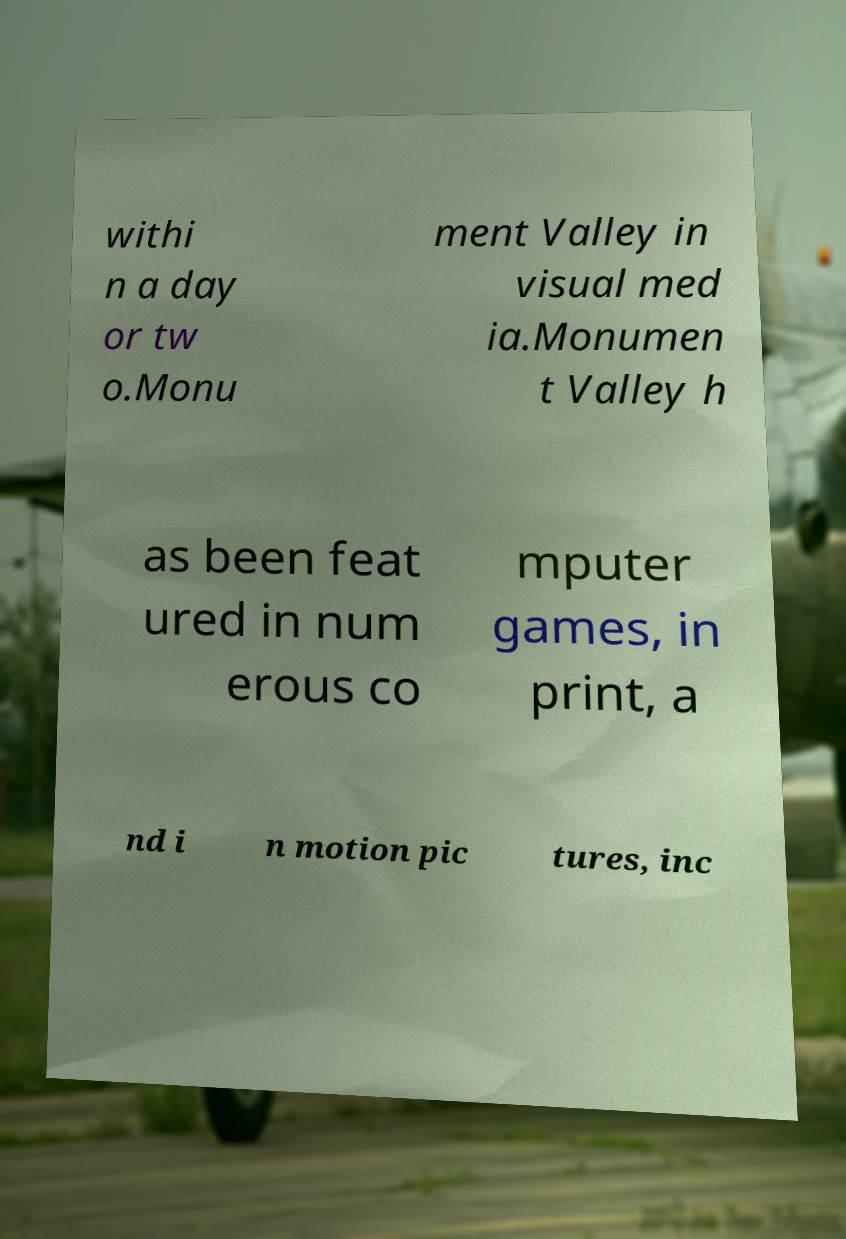Please identify and transcribe the text found in this image. withi n a day or tw o.Monu ment Valley in visual med ia.Monumen t Valley h as been feat ured in num erous co mputer games, in print, a nd i n motion pic tures, inc 